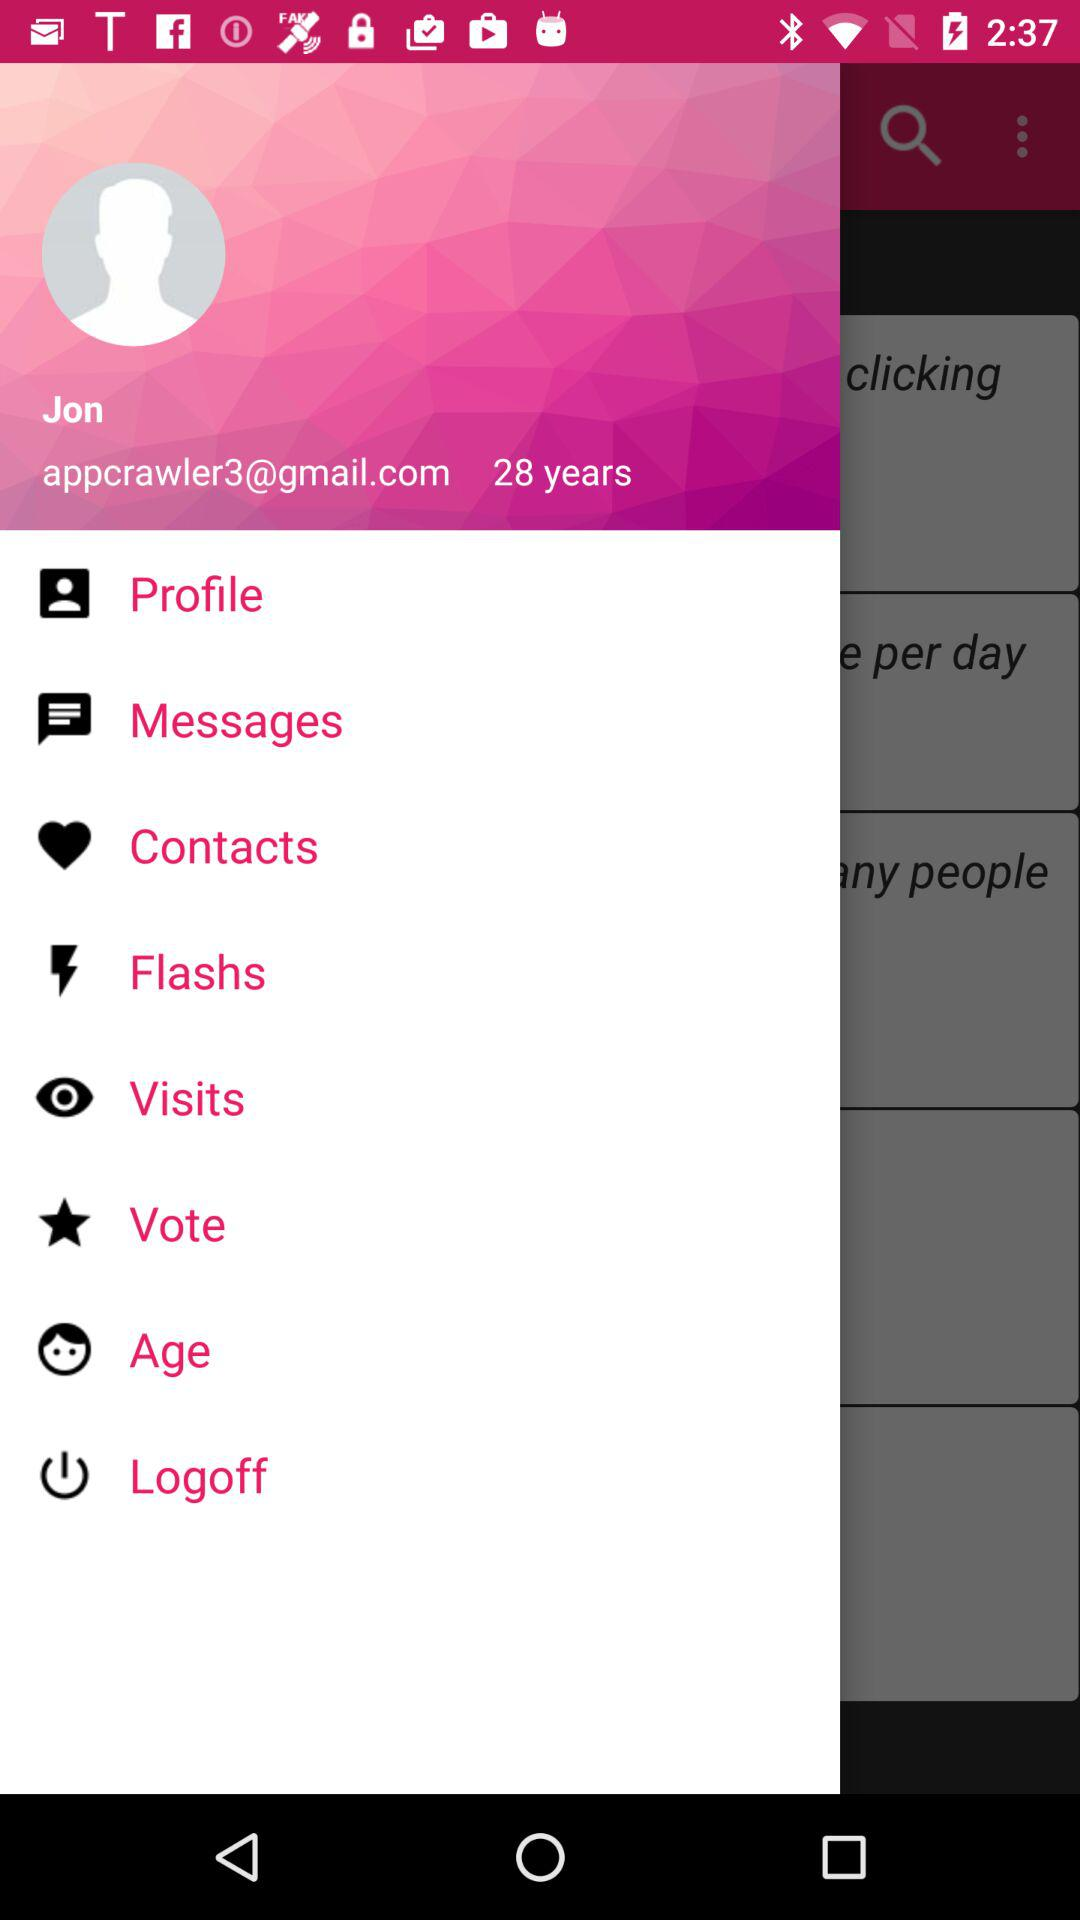What is the email address? The email address is appcrawler3@gmail.com. 